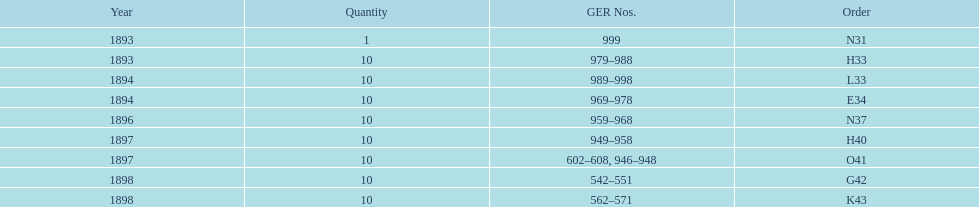How many years are listed? 5. Could you parse the entire table? {'header': ['Year', 'Quantity', 'GER Nos.', 'Order'], 'rows': [['1893', '1', '999', 'N31'], ['1893', '10', '979–988', 'H33'], ['1894', '10', '989–998', 'L33'], ['1894', '10', '969–978', 'E34'], ['1896', '10', '959–968', 'N37'], ['1897', '10', '949–958', 'H40'], ['1897', '10', '602–608, 946–948', 'O41'], ['1898', '10', '542–551', 'G42'], ['1898', '10', '562–571', 'K43']]} 